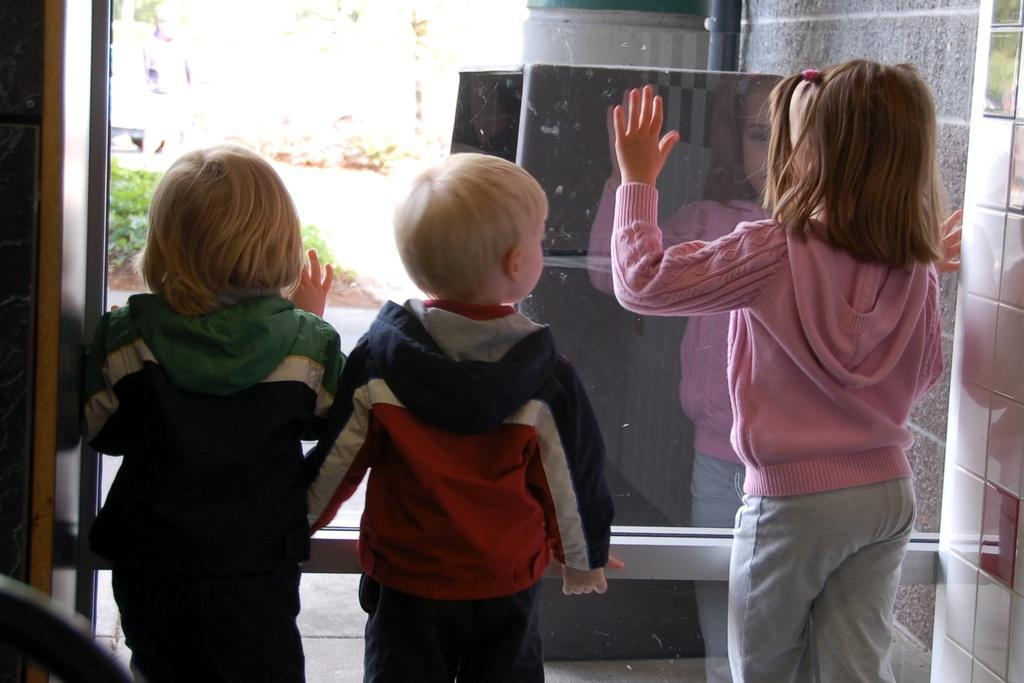How many children are present in the image? There are three kids in the image. What are the kids doing in the image? The kids are standing in the image. What type of surface is visible in the middle of the image? There is grass in the middle of the image. Can you see the mother of the kids in the image? There is no mother present in the image; only the three kids are visible. Are there any bees buzzing around the kids in the image? There is no mention of bees in the image, so we cannot determine if they are present or not. 